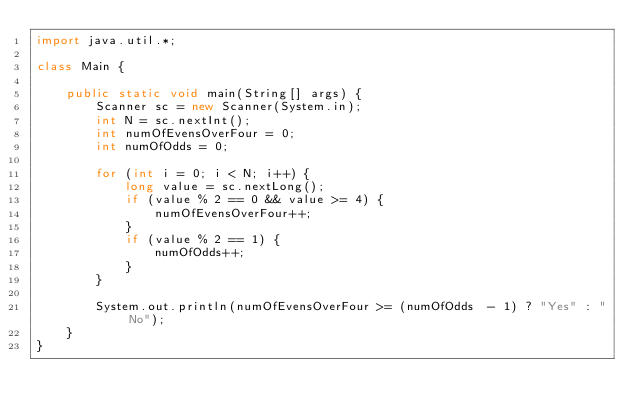<code> <loc_0><loc_0><loc_500><loc_500><_Java_>import java.util.*;

class Main {

    public static void main(String[] args) {
        Scanner sc = new Scanner(System.in);
        int N = sc.nextInt();
        int numOfEvensOverFour = 0;
        int numOfOdds = 0;

        for (int i = 0; i < N; i++) {
            long value = sc.nextLong();
            if (value % 2 == 0 && value >= 4) {
                numOfEvensOverFour++;
            }
            if (value % 2 == 1) {
                numOfOdds++;
            }
        }

        System.out.println(numOfEvensOverFour >= (numOfOdds  - 1) ? "Yes" : "No");
    }
}</code> 